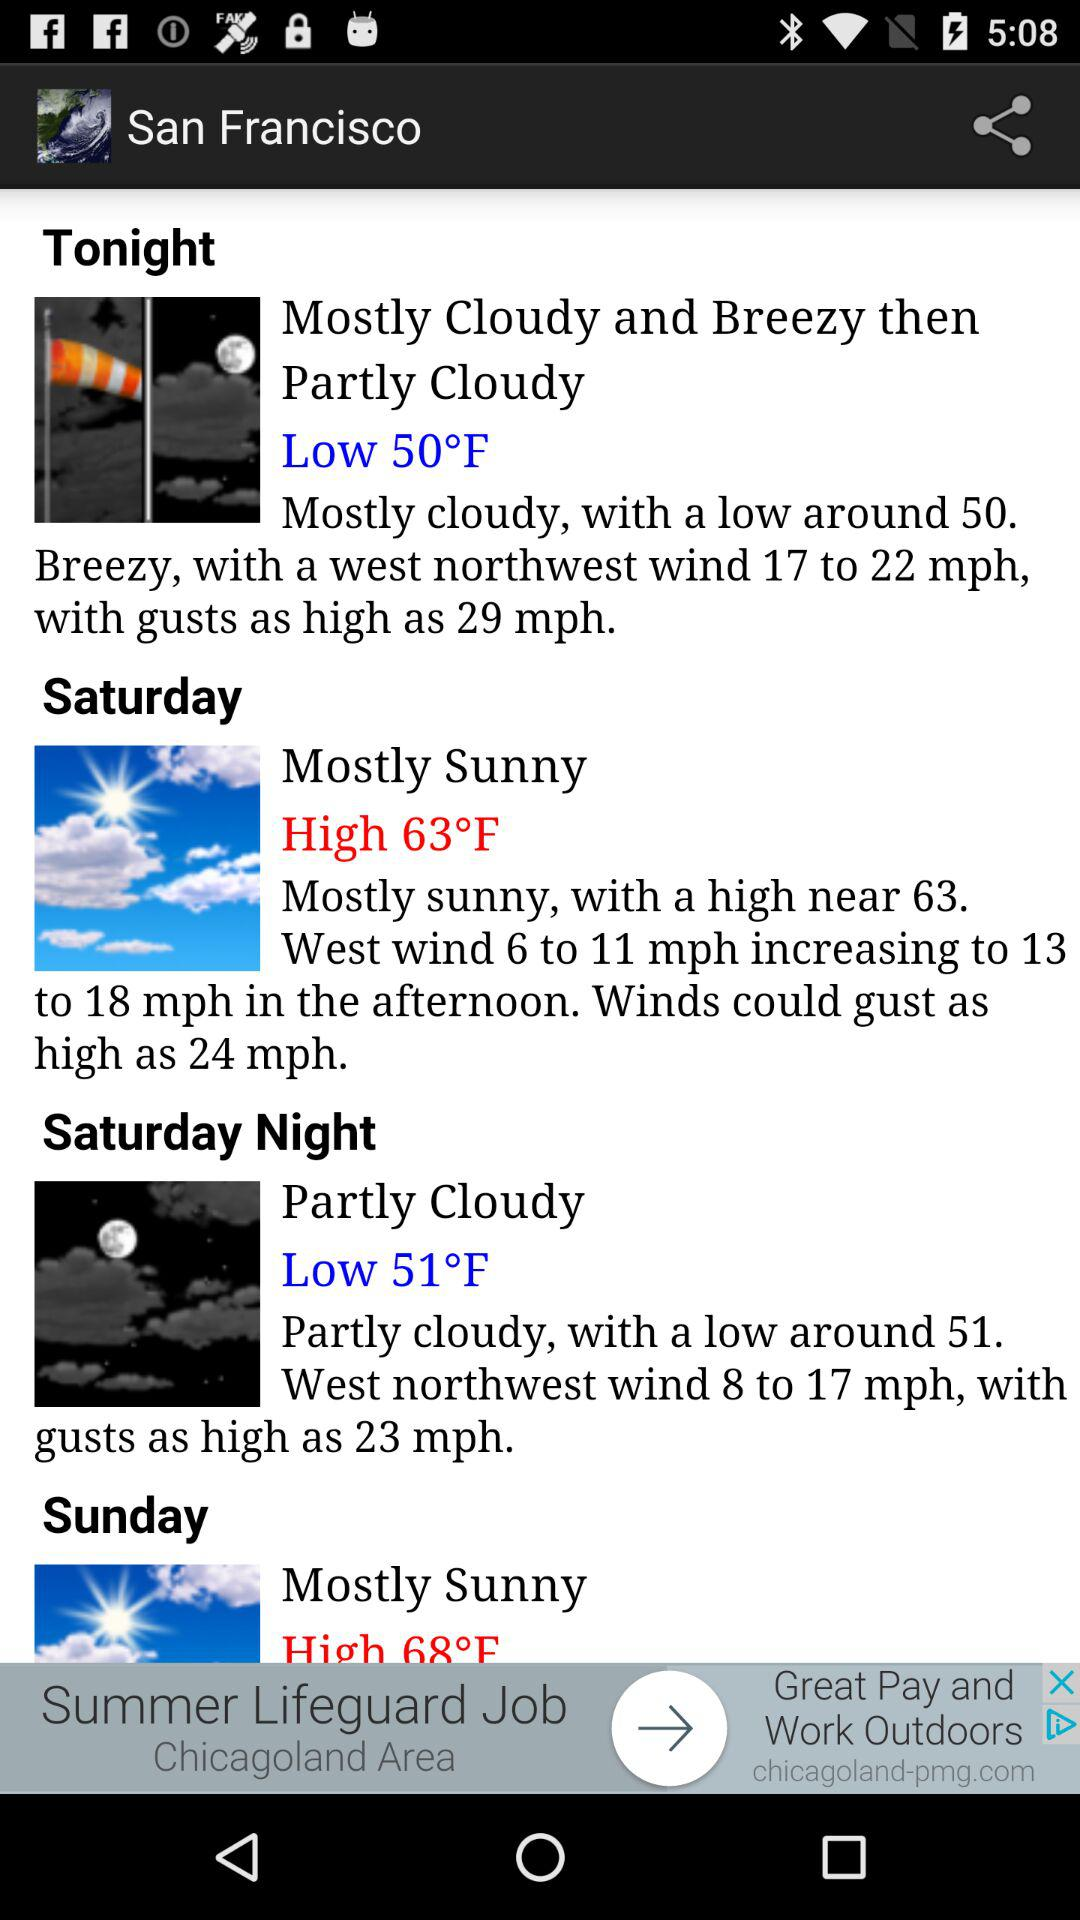How many degrees warmer is the high on Saturday than the low tonight?
Answer the question using a single word or phrase. 13 